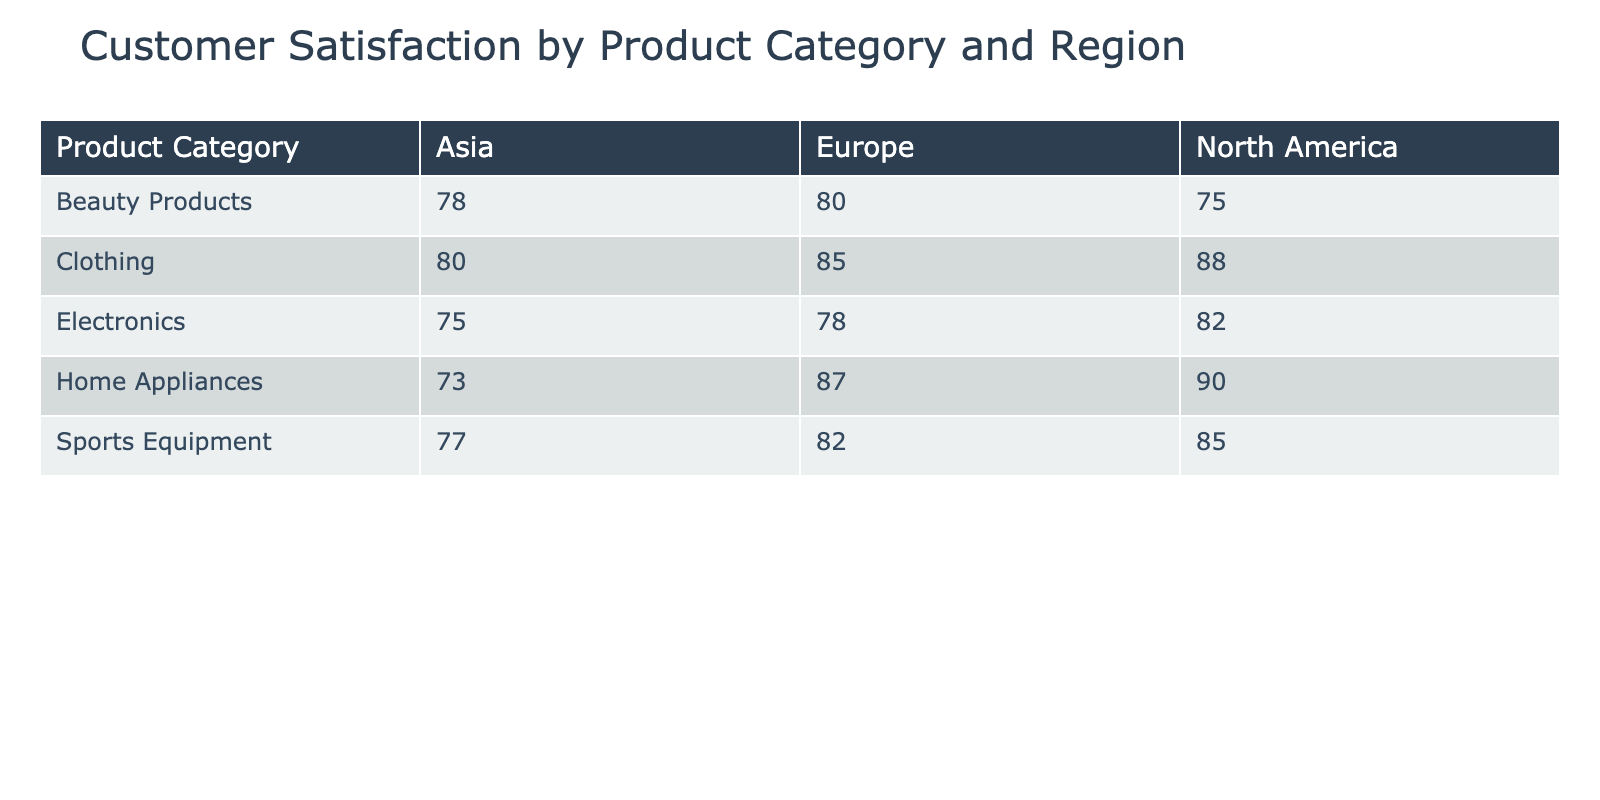What is the customer satisfaction score for Electronics in Asia? The table shows that the customer satisfaction score for Electronics in Asia is 75.
Answer: 75 What is the highest customer satisfaction score among the product categories in North America? Looking at the scores for North America, Home Appliances has the highest score of 90 compared to Electronics (82), Clothing (88), Beauty Products (75), and Sports Equipment (85).
Answer: 90 Which product category has the lowest customer satisfaction score in Europe? Checking the scores for Europe, Beauty Products has the lowest score of 80, while other categories score higher: Electronics (78), Clothing (85), Home Appliances (87), and Sports Equipment (82).
Answer: 80 What is the average customer satisfaction score for Clothing across all regions? The scores for Clothing are 88 (North America), 85 (Europe), and 80 (Asia). To find the average, sum these scores: 88 + 85 + 80 = 253. There are 3 scores, so the average is 253 / 3 = 84.3.
Answer: 84.3 Is customer satisfaction for Beauty Products higher in North America than in Asia? The customer satisfaction score for Beauty Products in North America is 75, while in Asia it is 78. Since 78 is greater than 75, the statement is false.
Answer: No Which product category has the greatest difference in customer satisfaction score between North America and Asia? Calculating the differences: Electronics (82 - 75 = 7), Clothing (88 - 80 = 8), Home Appliances (90 - 73 = 17), Beauty Products (75 - 78 = -3), Sports Equipment (85 - 77 = 8). The largest difference is for Home Appliances, which has a difference of 17.
Answer: Home Appliances What region has the highest overall average customer satisfaction score across all product categories? To find the overall average by region, we calculate the average scores: North America: (82 + 88 + 90 + 75 + 85) / 5 = 84, Europe: (78 + 85 + 87 + 80 + 82) / 5 = 82, Asia: (75 + 80 + 73 + 78 + 77) / 5 = 76. North America has the highest average score at 84.
Answer: North America Are customer satisfaction scores for Home Appliances consistently higher in all regions? The scores for Home Appliances are 90 (North America), 87 (Europe), and 73 (Asia). Since Asia has a score of 73, which is lower than the other two regions, we conclude that the scores are not consistently higher.
Answer: No 